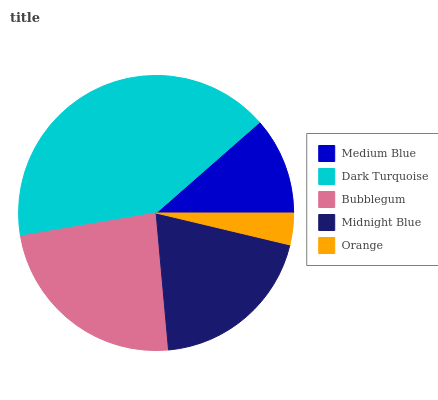Is Orange the minimum?
Answer yes or no. Yes. Is Dark Turquoise the maximum?
Answer yes or no. Yes. Is Bubblegum the minimum?
Answer yes or no. No. Is Bubblegum the maximum?
Answer yes or no. No. Is Dark Turquoise greater than Bubblegum?
Answer yes or no. Yes. Is Bubblegum less than Dark Turquoise?
Answer yes or no. Yes. Is Bubblegum greater than Dark Turquoise?
Answer yes or no. No. Is Dark Turquoise less than Bubblegum?
Answer yes or no. No. Is Midnight Blue the high median?
Answer yes or no. Yes. Is Midnight Blue the low median?
Answer yes or no. Yes. Is Medium Blue the high median?
Answer yes or no. No. Is Dark Turquoise the low median?
Answer yes or no. No. 